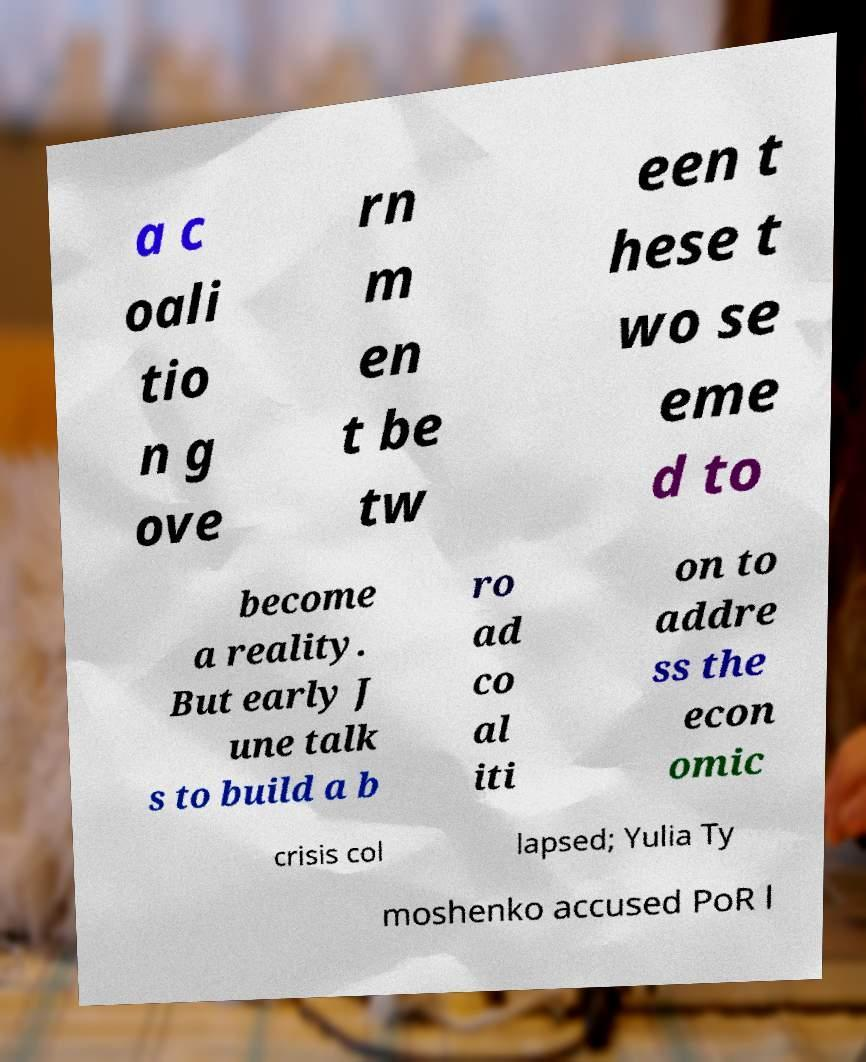Please read and relay the text visible in this image. What does it say? a c oali tio n g ove rn m en t be tw een t hese t wo se eme d to become a reality. But early J une talk s to build a b ro ad co al iti on to addre ss the econ omic crisis col lapsed; Yulia Ty moshenko accused PoR l 